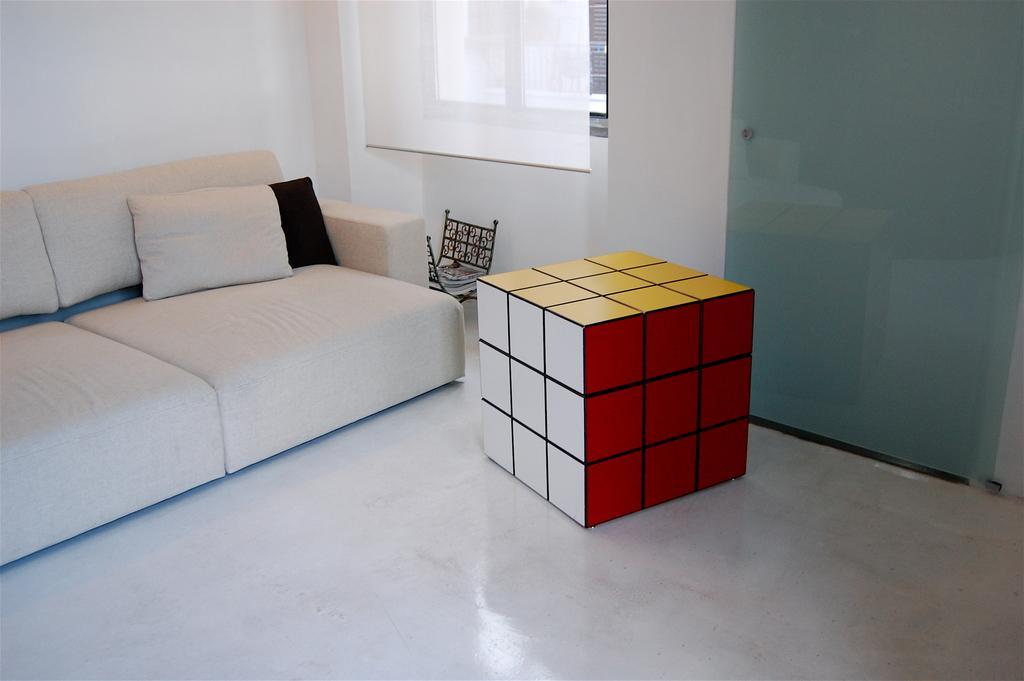In one or two sentences, can you explain what this image depicts? This is a picture of a living room. In the center of the picture there is a cube. To the left there is a couch, on the couch there is a pillow. In the center of the background there is a window. To the left it is well. To the top right there is a door. In the center of the picture there is a stand and some books in it. 